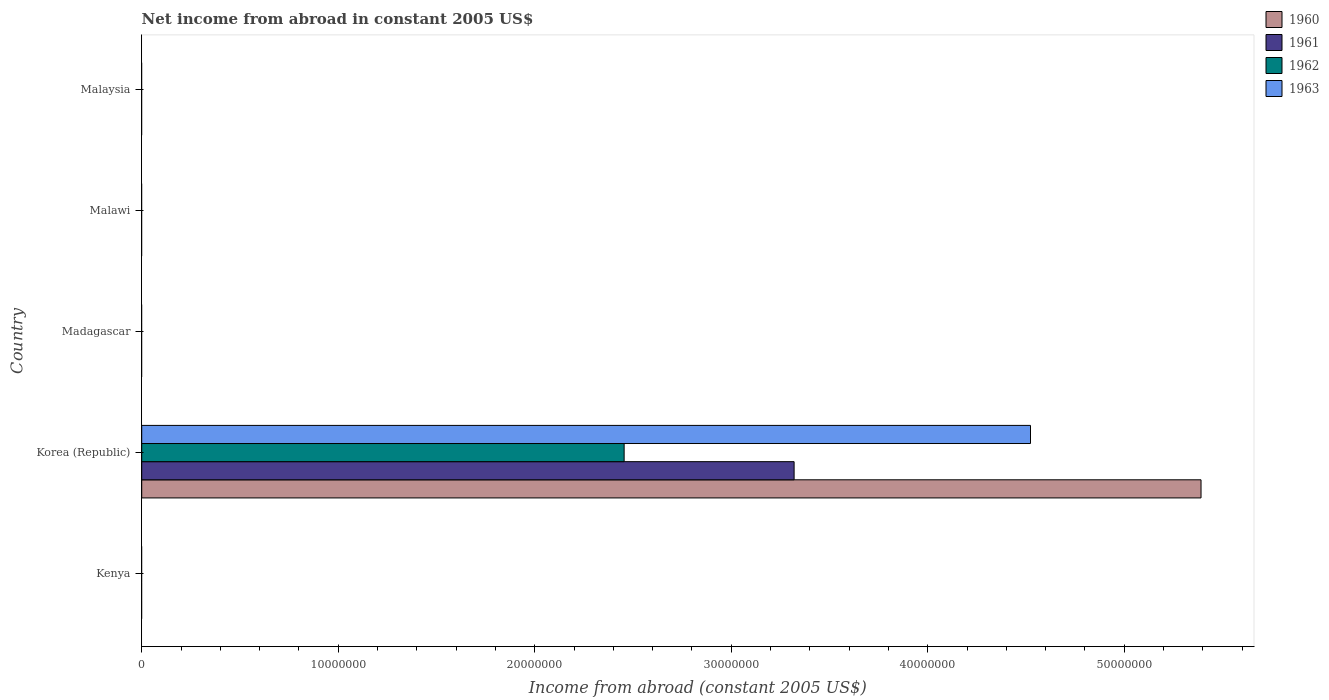How many different coloured bars are there?
Ensure brevity in your answer.  4. Are the number of bars per tick equal to the number of legend labels?
Give a very brief answer. No. Are the number of bars on each tick of the Y-axis equal?
Keep it short and to the point. No. How many bars are there on the 1st tick from the bottom?
Your response must be concise. 0. What is the label of the 5th group of bars from the top?
Your answer should be compact. Kenya. Across all countries, what is the maximum net income from abroad in 1961?
Make the answer very short. 3.32e+07. What is the total net income from abroad in 1962 in the graph?
Provide a succinct answer. 2.45e+07. What is the difference between the net income from abroad in 1961 in Malawi and the net income from abroad in 1962 in Madagascar?
Provide a short and direct response. 0. What is the average net income from abroad in 1963 per country?
Keep it short and to the point. 9.05e+06. What is the difference between the net income from abroad in 1961 and net income from abroad in 1960 in Korea (Republic)?
Make the answer very short. -2.07e+07. In how many countries, is the net income from abroad in 1962 greater than 6000000 US$?
Give a very brief answer. 1. What is the difference between the highest and the lowest net income from abroad in 1961?
Provide a succinct answer. 3.32e+07. In how many countries, is the net income from abroad in 1961 greater than the average net income from abroad in 1961 taken over all countries?
Your response must be concise. 1. Is it the case that in every country, the sum of the net income from abroad in 1961 and net income from abroad in 1962 is greater than the sum of net income from abroad in 1960 and net income from abroad in 1963?
Your answer should be very brief. No. Is it the case that in every country, the sum of the net income from abroad in 1961 and net income from abroad in 1962 is greater than the net income from abroad in 1963?
Keep it short and to the point. No. Are all the bars in the graph horizontal?
Give a very brief answer. Yes. What is the difference between two consecutive major ticks on the X-axis?
Ensure brevity in your answer.  1.00e+07. Where does the legend appear in the graph?
Keep it short and to the point. Top right. What is the title of the graph?
Give a very brief answer. Net income from abroad in constant 2005 US$. What is the label or title of the X-axis?
Provide a short and direct response. Income from abroad (constant 2005 US$). What is the Income from abroad (constant 2005 US$) in 1961 in Kenya?
Make the answer very short. 0. What is the Income from abroad (constant 2005 US$) of 1963 in Kenya?
Your answer should be very brief. 0. What is the Income from abroad (constant 2005 US$) in 1960 in Korea (Republic)?
Ensure brevity in your answer.  5.39e+07. What is the Income from abroad (constant 2005 US$) of 1961 in Korea (Republic)?
Offer a very short reply. 3.32e+07. What is the Income from abroad (constant 2005 US$) of 1962 in Korea (Republic)?
Offer a very short reply. 2.45e+07. What is the Income from abroad (constant 2005 US$) of 1963 in Korea (Republic)?
Offer a very short reply. 4.52e+07. What is the Income from abroad (constant 2005 US$) in 1960 in Madagascar?
Your answer should be compact. 0. What is the Income from abroad (constant 2005 US$) in 1962 in Madagascar?
Your answer should be very brief. 0. What is the Income from abroad (constant 2005 US$) in 1961 in Malawi?
Your answer should be very brief. 0. What is the Income from abroad (constant 2005 US$) in 1960 in Malaysia?
Make the answer very short. 0. Across all countries, what is the maximum Income from abroad (constant 2005 US$) of 1960?
Your answer should be compact. 5.39e+07. Across all countries, what is the maximum Income from abroad (constant 2005 US$) in 1961?
Provide a succinct answer. 3.32e+07. Across all countries, what is the maximum Income from abroad (constant 2005 US$) in 1962?
Offer a very short reply. 2.45e+07. Across all countries, what is the maximum Income from abroad (constant 2005 US$) of 1963?
Offer a very short reply. 4.52e+07. Across all countries, what is the minimum Income from abroad (constant 2005 US$) in 1961?
Your answer should be very brief. 0. What is the total Income from abroad (constant 2005 US$) of 1960 in the graph?
Offer a terse response. 5.39e+07. What is the total Income from abroad (constant 2005 US$) in 1961 in the graph?
Make the answer very short. 3.32e+07. What is the total Income from abroad (constant 2005 US$) of 1962 in the graph?
Give a very brief answer. 2.45e+07. What is the total Income from abroad (constant 2005 US$) in 1963 in the graph?
Give a very brief answer. 4.52e+07. What is the average Income from abroad (constant 2005 US$) of 1960 per country?
Your response must be concise. 1.08e+07. What is the average Income from abroad (constant 2005 US$) in 1961 per country?
Provide a short and direct response. 6.64e+06. What is the average Income from abroad (constant 2005 US$) of 1962 per country?
Ensure brevity in your answer.  4.91e+06. What is the average Income from abroad (constant 2005 US$) in 1963 per country?
Offer a terse response. 9.05e+06. What is the difference between the Income from abroad (constant 2005 US$) of 1960 and Income from abroad (constant 2005 US$) of 1961 in Korea (Republic)?
Give a very brief answer. 2.07e+07. What is the difference between the Income from abroad (constant 2005 US$) of 1960 and Income from abroad (constant 2005 US$) of 1962 in Korea (Republic)?
Ensure brevity in your answer.  2.94e+07. What is the difference between the Income from abroad (constant 2005 US$) of 1960 and Income from abroad (constant 2005 US$) of 1963 in Korea (Republic)?
Ensure brevity in your answer.  8.68e+06. What is the difference between the Income from abroad (constant 2005 US$) in 1961 and Income from abroad (constant 2005 US$) in 1962 in Korea (Republic)?
Offer a terse response. 8.65e+06. What is the difference between the Income from abroad (constant 2005 US$) of 1961 and Income from abroad (constant 2005 US$) of 1963 in Korea (Republic)?
Give a very brief answer. -1.20e+07. What is the difference between the Income from abroad (constant 2005 US$) in 1962 and Income from abroad (constant 2005 US$) in 1963 in Korea (Republic)?
Give a very brief answer. -2.07e+07. What is the difference between the highest and the lowest Income from abroad (constant 2005 US$) in 1960?
Ensure brevity in your answer.  5.39e+07. What is the difference between the highest and the lowest Income from abroad (constant 2005 US$) in 1961?
Provide a succinct answer. 3.32e+07. What is the difference between the highest and the lowest Income from abroad (constant 2005 US$) of 1962?
Keep it short and to the point. 2.45e+07. What is the difference between the highest and the lowest Income from abroad (constant 2005 US$) of 1963?
Make the answer very short. 4.52e+07. 